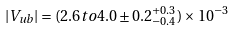<formula> <loc_0><loc_0><loc_500><loc_500>| V _ { u b } | = ( 2 . 6 t o 4 . 0 \pm 0 . 2 _ { - 0 . 4 } ^ { + 0 . 3 } ) \times 1 0 ^ { - 3 }</formula> 